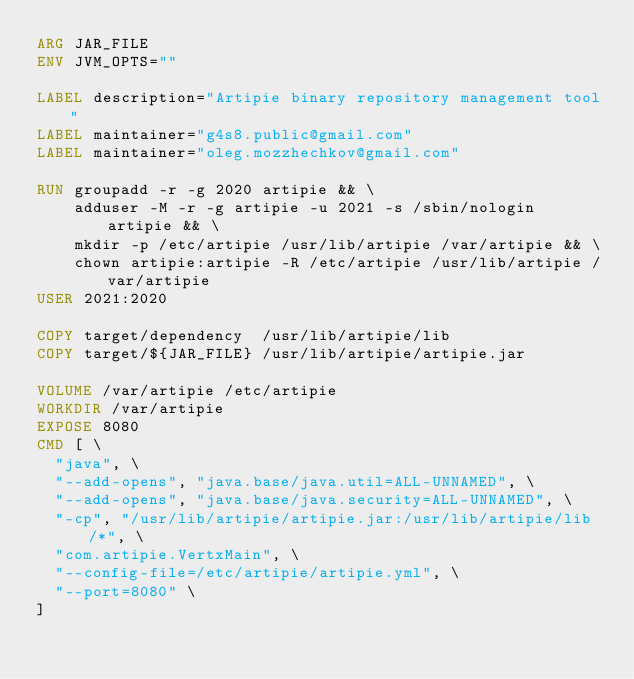<code> <loc_0><loc_0><loc_500><loc_500><_Dockerfile_>ARG JAR_FILE
ENV JVM_OPTS=""

LABEL description="Artipie binary repository management tool"
LABEL maintainer="g4s8.public@gmail.com"
LABEL maintainer="oleg.mozzhechkov@gmail.com"

RUN groupadd -r -g 2020 artipie && \
    adduser -M -r -g artipie -u 2021 -s /sbin/nologin artipie && \
    mkdir -p /etc/artipie /usr/lib/artipie /var/artipie && \
    chown artipie:artipie -R /etc/artipie /usr/lib/artipie /var/artipie
USER 2021:2020

COPY target/dependency  /usr/lib/artipie/lib
COPY target/${JAR_FILE} /usr/lib/artipie/artipie.jar

VOLUME /var/artipie /etc/artipie
WORKDIR /var/artipie
EXPOSE 8080
CMD [ \
  "java", \
  "--add-opens", "java.base/java.util=ALL-UNNAMED", \
  "--add-opens", "java.base/java.security=ALL-UNNAMED", \
  "-cp", "/usr/lib/artipie/artipie.jar:/usr/lib/artipie/lib/*", \
  "com.artipie.VertxMain", \
  "--config-file=/etc/artipie/artipie.yml", \
  "--port=8080" \
]
</code> 